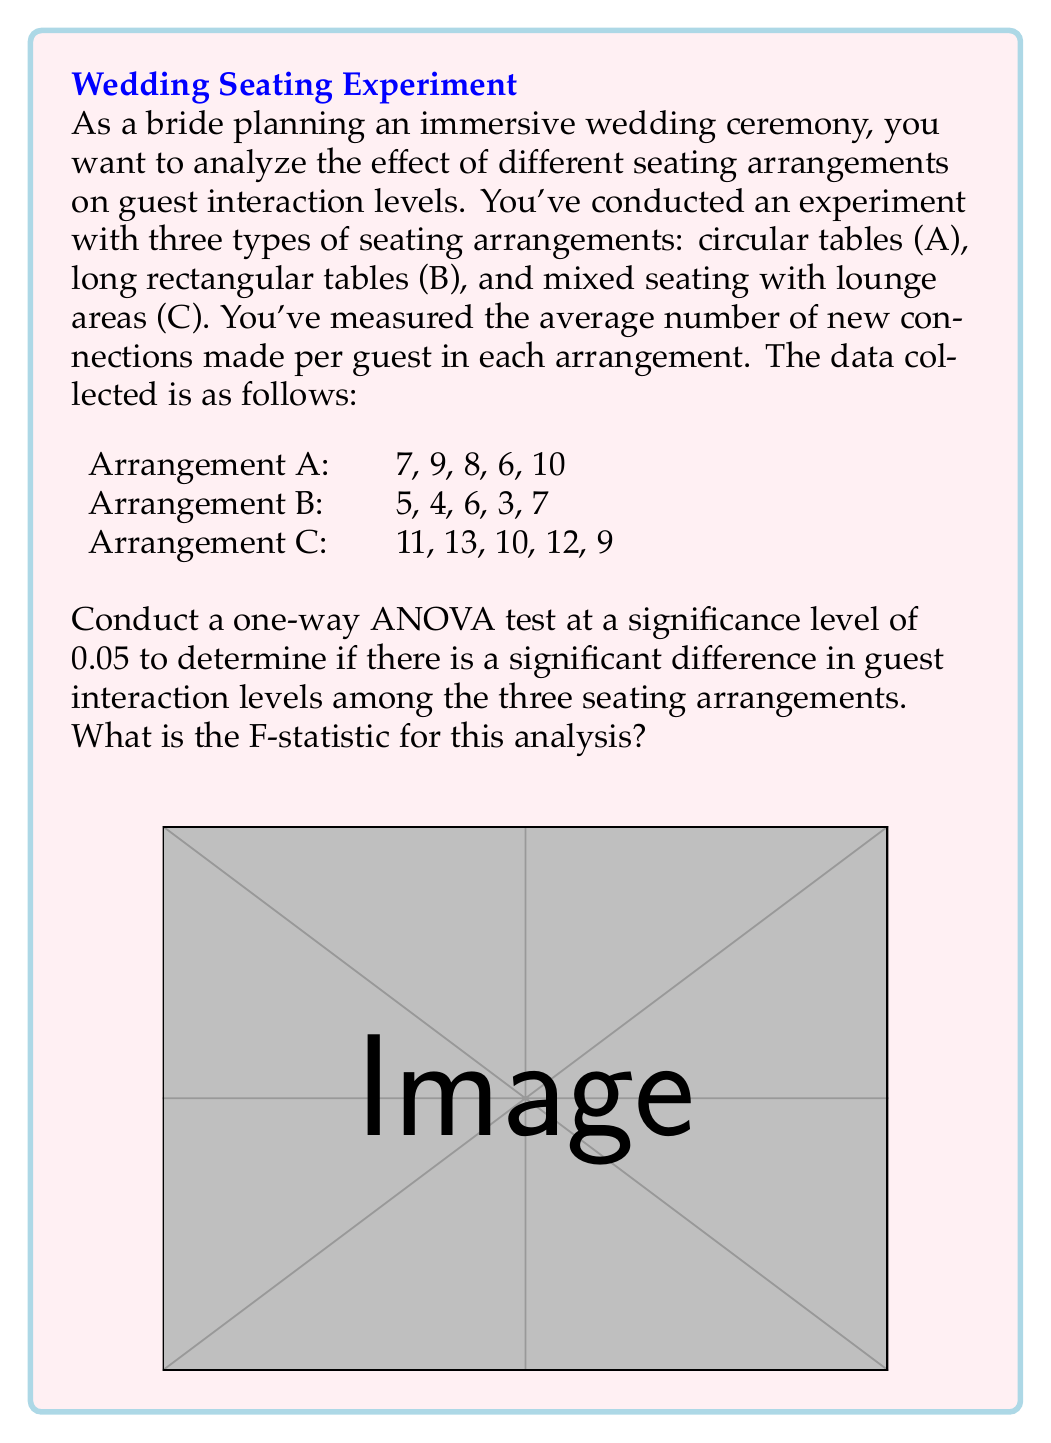Teach me how to tackle this problem. To conduct a one-way ANOVA test and calculate the F-statistic, we'll follow these steps:

1. Calculate the mean for each group:
   $$\bar{X}_A = \frac{7+9+8+6+10}{5} = 8$$
   $$\bar{X}_B = \frac{5+4+6+3+7}{5} = 5$$
   $$\bar{X}_C = \frac{11+13+10+12+9}{5} = 11$$

2. Calculate the grand mean:
   $$\bar{X} = \frac{8+5+11}{3} = 8$$

3. Calculate the Sum of Squares Between groups (SSB):
   $$SSB = 5[(8-8)^2 + (5-8)^2 + (11-8)^2] = 5(0 + 9 + 9) = 90$$

4. Calculate the Sum of Squares Within groups (SSW):
   $$SSW_A = (7-8)^2 + (9-8)^2 + (8-8)^2 + (6-8)^2 + (10-8)^2 = 10$$
   $$SSW_B = (5-5)^2 + (4-5)^2 + (6-5)^2 + (3-5)^2 + (7-5)^2 = 10$$
   $$SSW_C = (11-11)^2 + (13-11)^2 + (10-11)^2 + (12-11)^2 + (9-11)^2 = 10$$
   $$SSW = SSW_A + SSW_B + SSW_C = 10 + 10 + 10 = 30$$

5. Calculate degrees of freedom:
   $$df_{between} = k - 1 = 3 - 1 = 2$$
   $$df_{within} = N - k = 15 - 3 = 12$$
   where k is the number of groups and N is the total number of observations.

6. Calculate Mean Square Between (MSB) and Mean Square Within (MSW):
   $$MSB = \frac{SSB}{df_{between}} = \frac{90}{2} = 45$$
   $$MSW = \frac{SSW}{df_{within}} = \frac{30}{12} = 2.5$$

7. Calculate the F-statistic:
   $$F = \frac{MSB}{MSW} = \frac{45}{2.5} = 18$$

Therefore, the F-statistic for this analysis is 18.
Answer: 18 